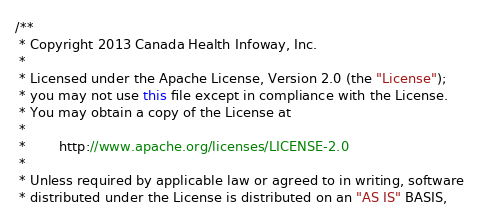Convert code to text. <code><loc_0><loc_0><loc_500><loc_500><_Java_>/**
 * Copyright 2013 Canada Health Infoway, Inc.
 *
 * Licensed under the Apache License, Version 2.0 (the "License");
 * you may not use this file except in compliance with the License.
 * You may obtain a copy of the License at
 *
 *        http://www.apache.org/licenses/LICENSE-2.0
 *
 * Unless required by applicable law or agreed to in writing, software
 * distributed under the License is distributed on an "AS IS" BASIS,</code> 